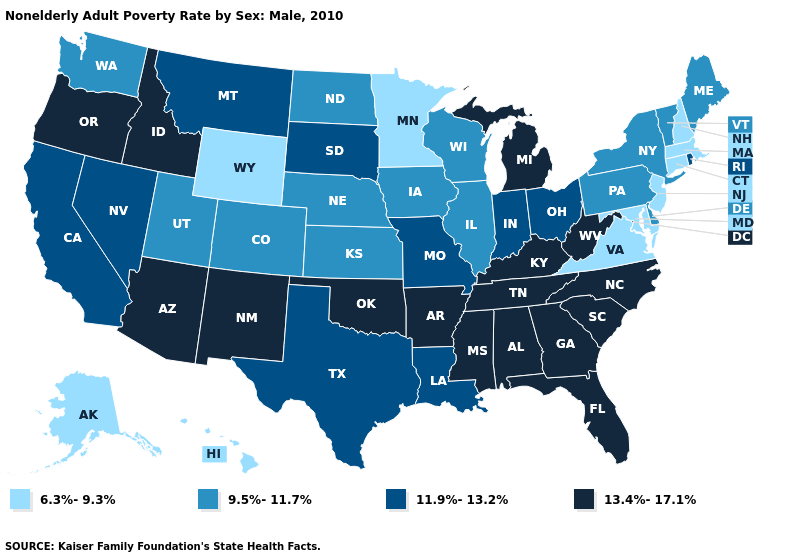Which states have the highest value in the USA?
Give a very brief answer. Alabama, Arizona, Arkansas, Florida, Georgia, Idaho, Kentucky, Michigan, Mississippi, New Mexico, North Carolina, Oklahoma, Oregon, South Carolina, Tennessee, West Virginia. Among the states that border Wisconsin , does Michigan have the highest value?
Give a very brief answer. Yes. What is the lowest value in the West?
Quick response, please. 6.3%-9.3%. What is the value of Michigan?
Give a very brief answer. 13.4%-17.1%. Which states have the lowest value in the USA?
Give a very brief answer. Alaska, Connecticut, Hawaii, Maryland, Massachusetts, Minnesota, New Hampshire, New Jersey, Virginia, Wyoming. Among the states that border Kentucky , does Ohio have the highest value?
Answer briefly. No. Which states have the highest value in the USA?
Keep it brief. Alabama, Arizona, Arkansas, Florida, Georgia, Idaho, Kentucky, Michigan, Mississippi, New Mexico, North Carolina, Oklahoma, Oregon, South Carolina, Tennessee, West Virginia. What is the highest value in states that border Massachusetts?
Be succinct. 11.9%-13.2%. What is the value of Alabama?
Give a very brief answer. 13.4%-17.1%. What is the highest value in the South ?
Be succinct. 13.4%-17.1%. What is the value of New Jersey?
Keep it brief. 6.3%-9.3%. Name the states that have a value in the range 9.5%-11.7%?
Short answer required. Colorado, Delaware, Illinois, Iowa, Kansas, Maine, Nebraska, New York, North Dakota, Pennsylvania, Utah, Vermont, Washington, Wisconsin. Does the first symbol in the legend represent the smallest category?
Concise answer only. Yes. Does the first symbol in the legend represent the smallest category?
Keep it brief. Yes. 